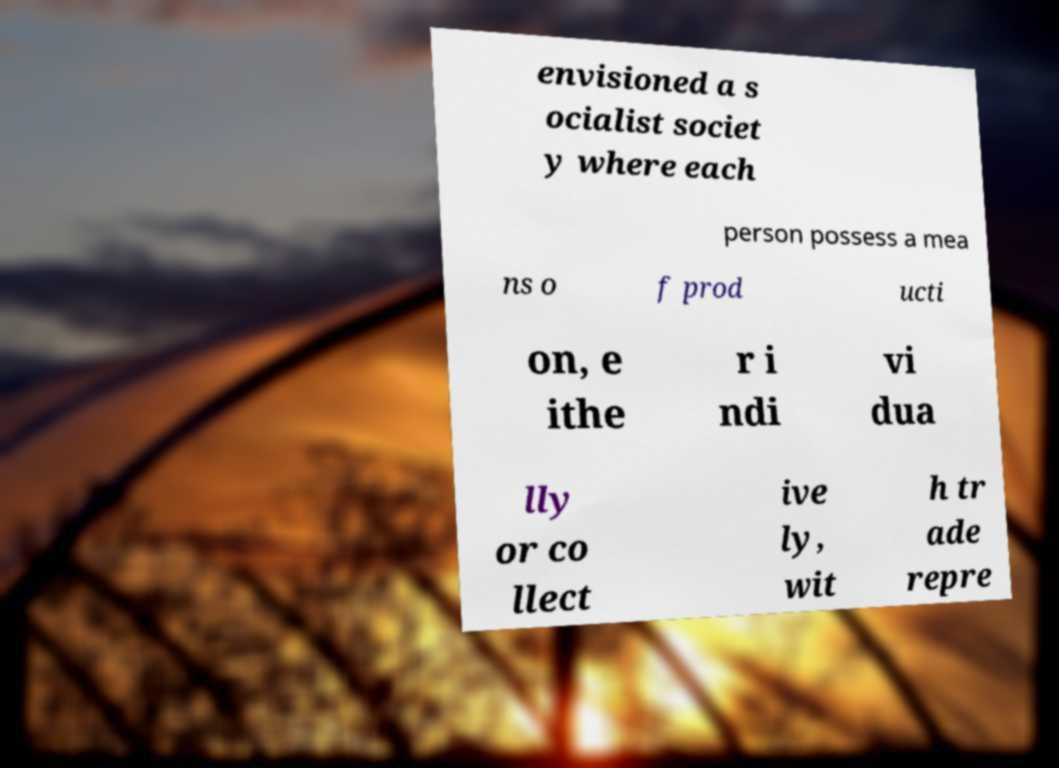Can you accurately transcribe the text from the provided image for me? envisioned a s ocialist societ y where each person possess a mea ns o f prod ucti on, e ithe r i ndi vi dua lly or co llect ive ly, wit h tr ade repre 